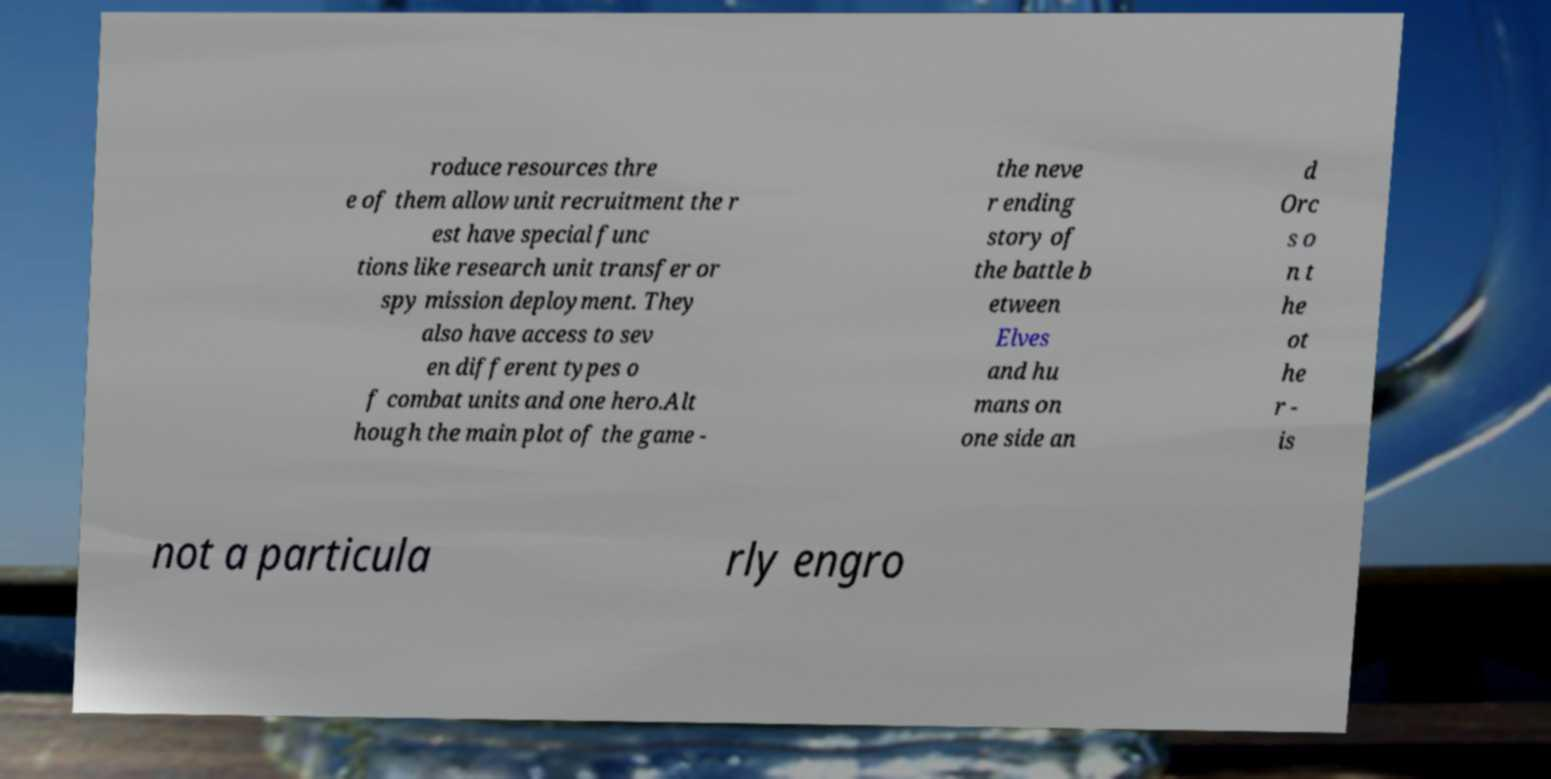Please identify and transcribe the text found in this image. roduce resources thre e of them allow unit recruitment the r est have special func tions like research unit transfer or spy mission deployment. They also have access to sev en different types o f combat units and one hero.Alt hough the main plot of the game - the neve r ending story of the battle b etween Elves and hu mans on one side an d Orc s o n t he ot he r - is not a particula rly engro 